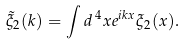Convert formula to latex. <formula><loc_0><loc_0><loc_500><loc_500>\tilde { \xi } _ { 2 } ( k ) = \int d ^ { \, 4 } x e ^ { i k x } \xi _ { 2 } ( x ) .</formula> 